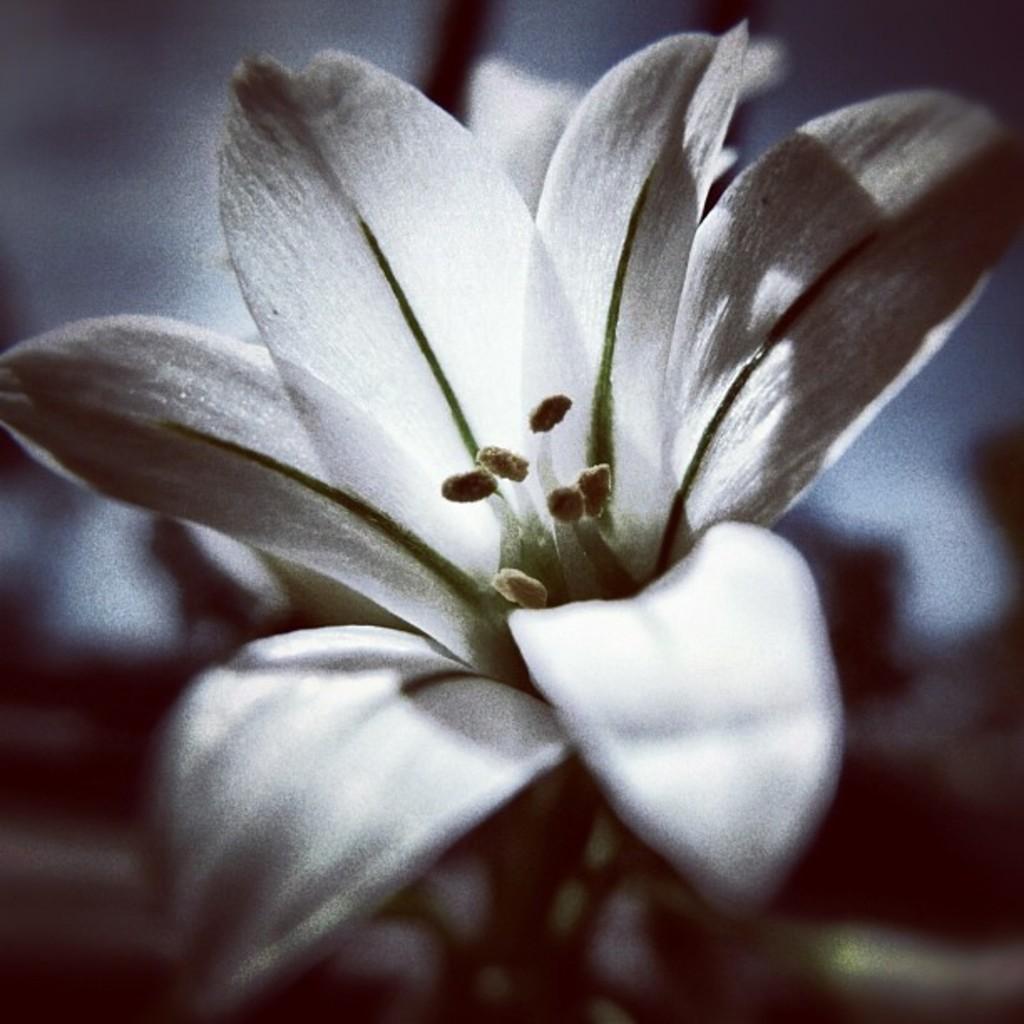Could you give a brief overview of what you see in this image? In this image we can see a flower and blur background. 